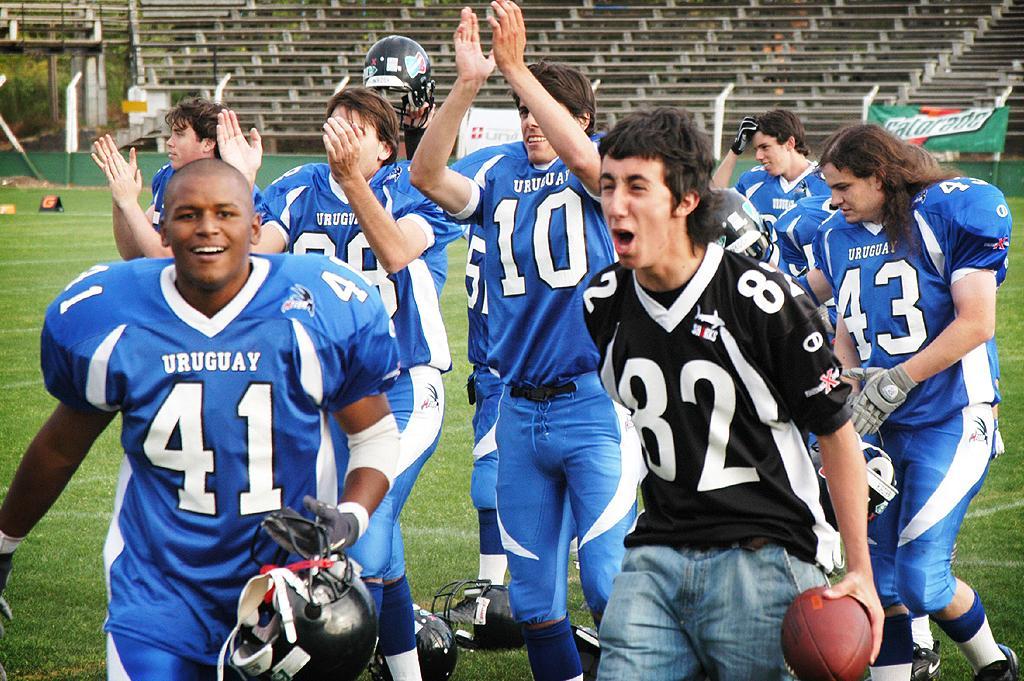How would you summarize this image in a sentence or two? In this image we can see sportspeople. The man standing on the right is holding a ball. In the background there are boards and we can see benches. 